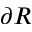Convert formula to latex. <formula><loc_0><loc_0><loc_500><loc_500>\partial R</formula> 